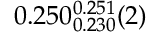Convert formula to latex. <formula><loc_0><loc_0><loc_500><loc_500>0 . 2 5 0 _ { 0 . 2 3 0 } ^ { 0 . 2 5 1 } ( 2 )</formula> 